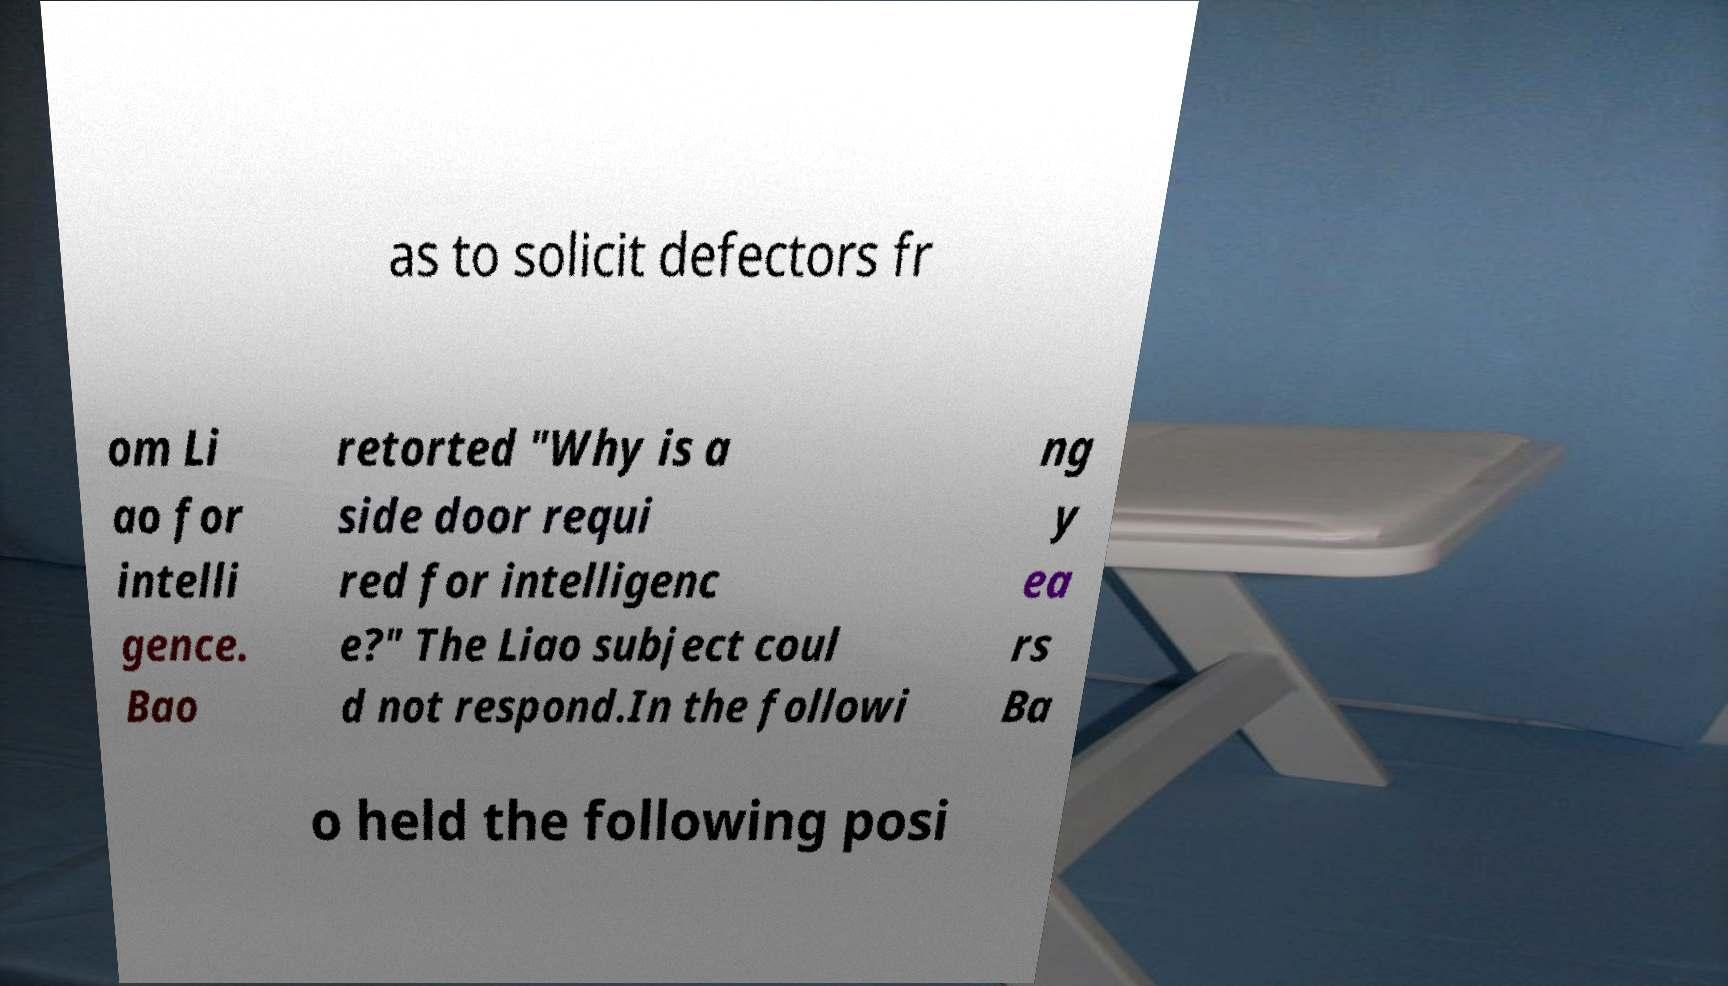Could you assist in decoding the text presented in this image and type it out clearly? as to solicit defectors fr om Li ao for intelli gence. Bao retorted "Why is a side door requi red for intelligenc e?" The Liao subject coul d not respond.In the followi ng y ea rs Ba o held the following posi 